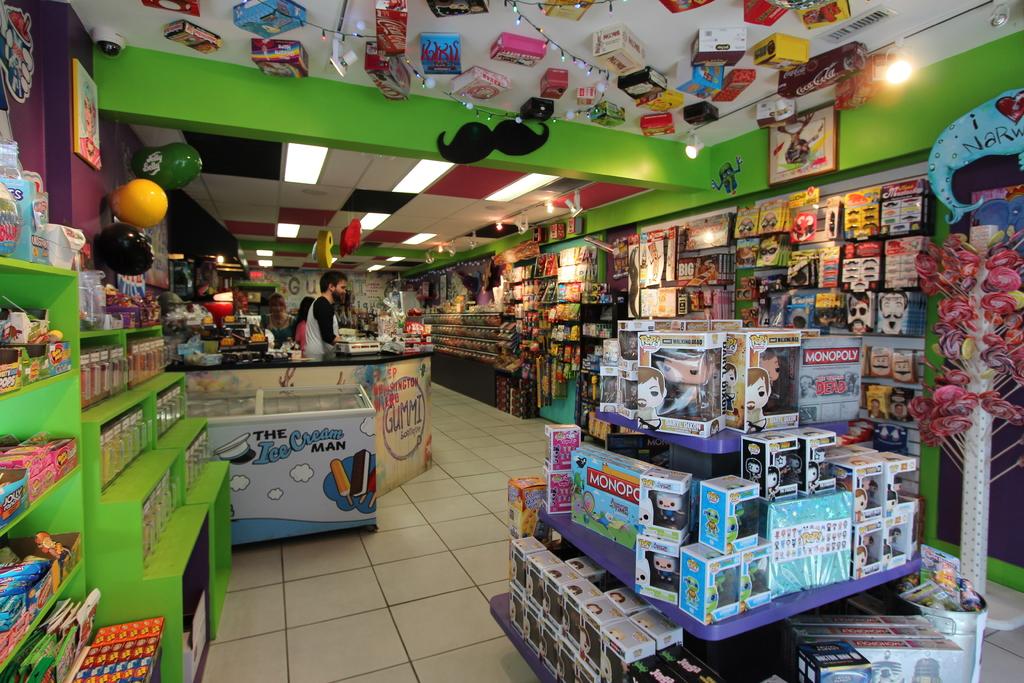What kind of man is mentioned here?
Offer a very short reply. Unanswerable. 